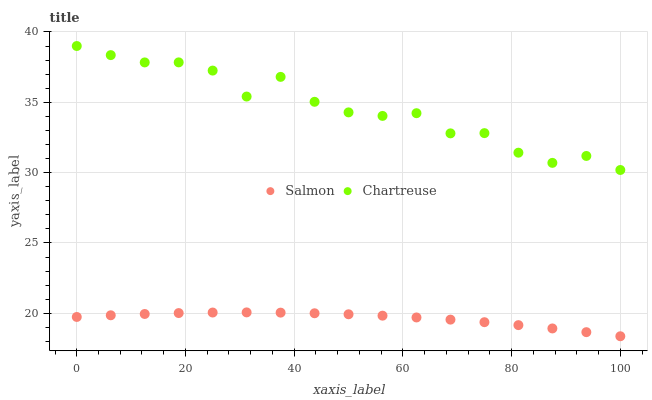Does Salmon have the minimum area under the curve?
Answer yes or no. Yes. Does Chartreuse have the maximum area under the curve?
Answer yes or no. Yes. Does Salmon have the maximum area under the curve?
Answer yes or no. No. Is Salmon the smoothest?
Answer yes or no. Yes. Is Chartreuse the roughest?
Answer yes or no. Yes. Is Salmon the roughest?
Answer yes or no. No. Does Salmon have the lowest value?
Answer yes or no. Yes. Does Chartreuse have the highest value?
Answer yes or no. Yes. Does Salmon have the highest value?
Answer yes or no. No. Is Salmon less than Chartreuse?
Answer yes or no. Yes. Is Chartreuse greater than Salmon?
Answer yes or no. Yes. Does Salmon intersect Chartreuse?
Answer yes or no. No. 